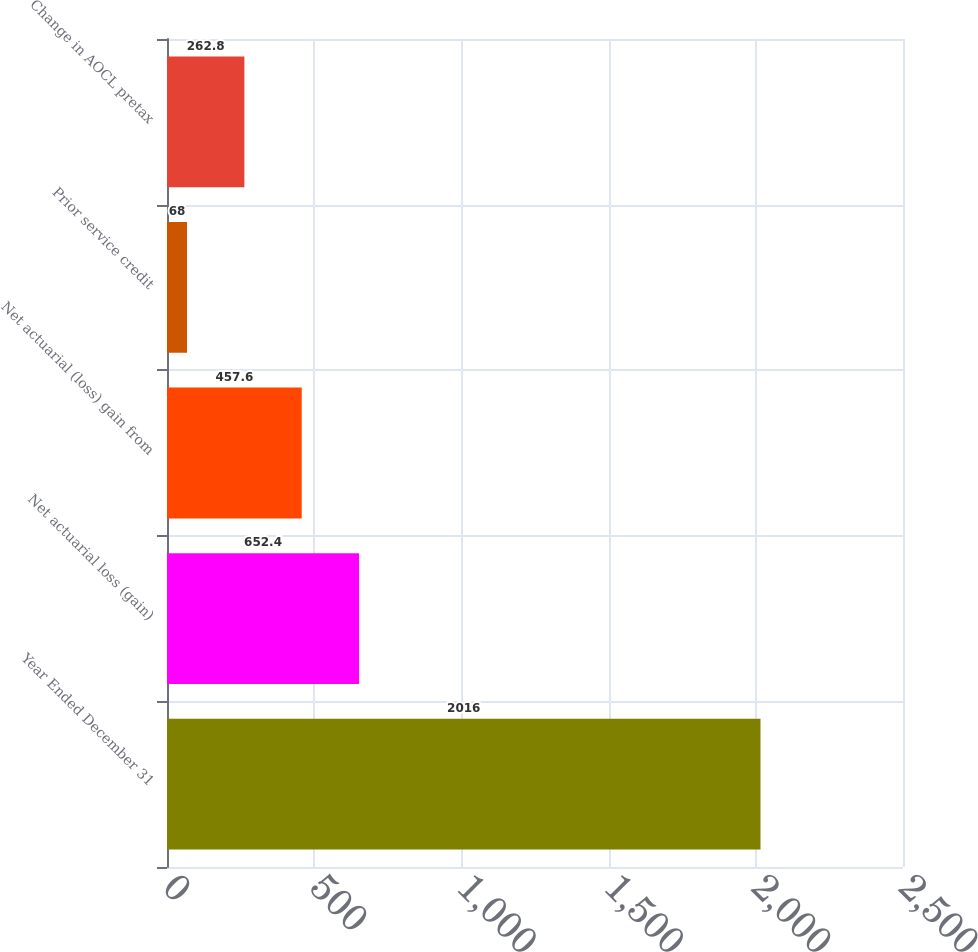<chart> <loc_0><loc_0><loc_500><loc_500><bar_chart><fcel>Year Ended December 31<fcel>Net actuarial loss (gain)<fcel>Net actuarial (loss) gain from<fcel>Prior service credit<fcel>Change in AOCL pretax<nl><fcel>2016<fcel>652.4<fcel>457.6<fcel>68<fcel>262.8<nl></chart> 